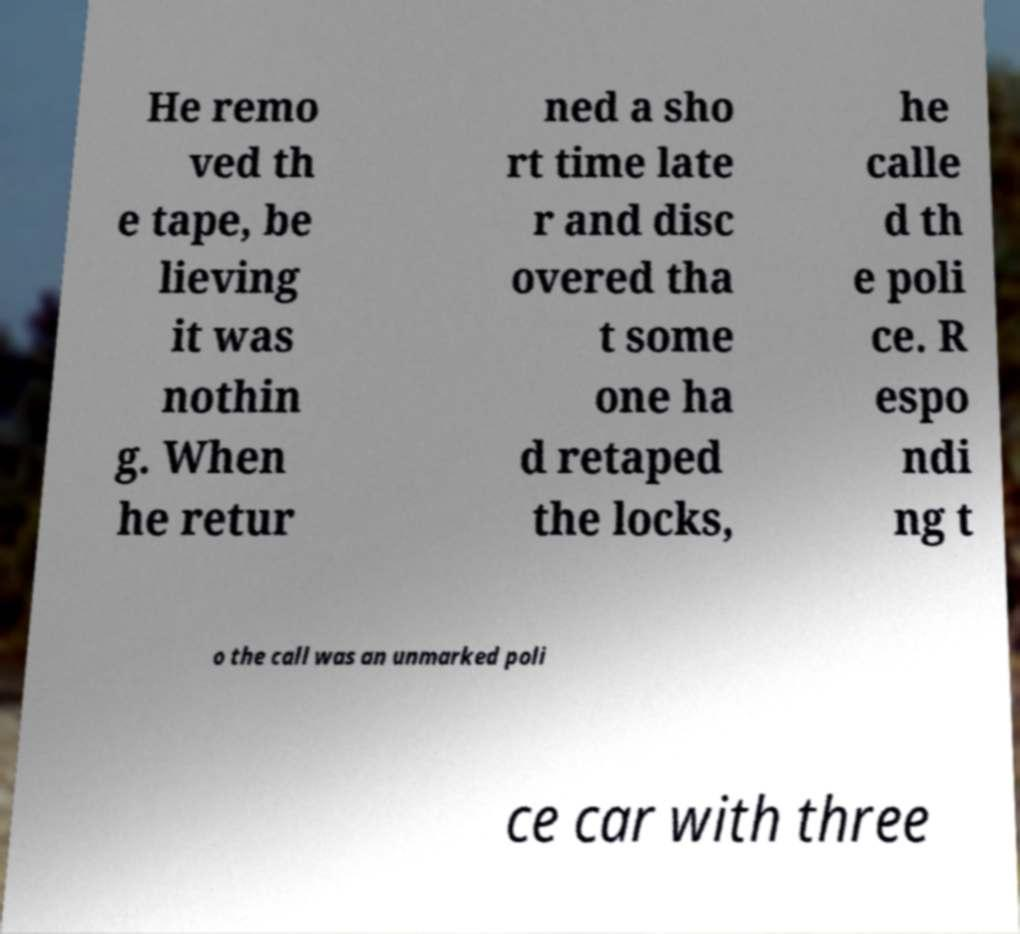There's text embedded in this image that I need extracted. Can you transcribe it verbatim? He remo ved th e tape, be lieving it was nothin g. When he retur ned a sho rt time late r and disc overed tha t some one ha d retaped the locks, he calle d th e poli ce. R espo ndi ng t o the call was an unmarked poli ce car with three 